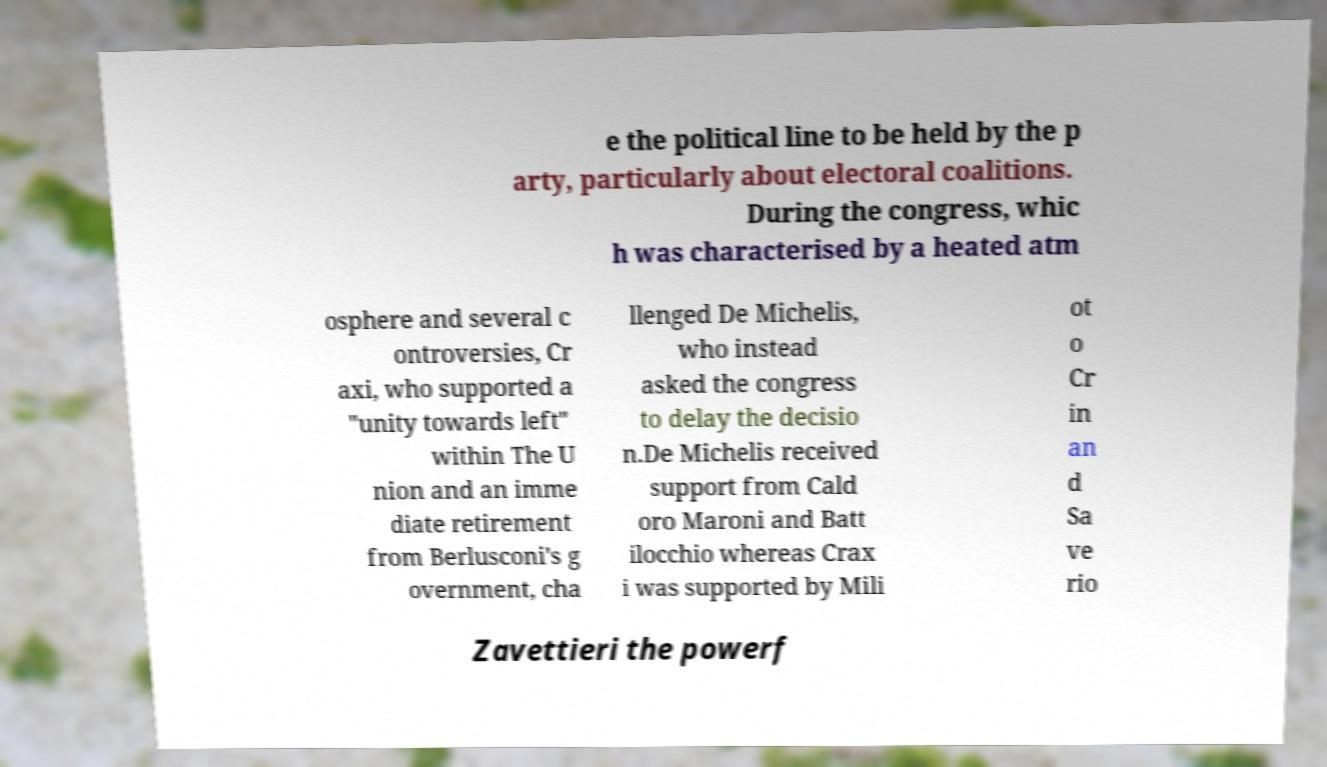Please identify and transcribe the text found in this image. e the political line to be held by the p arty, particularly about electoral coalitions. During the congress, whic h was characterised by a heated atm osphere and several c ontroversies, Cr axi, who supported a "unity towards left" within The U nion and an imme diate retirement from Berlusconi's g overnment, cha llenged De Michelis, who instead asked the congress to delay the decisio n.De Michelis received support from Cald oro Maroni and Batt ilocchio whereas Crax i was supported by Mili ot o Cr in an d Sa ve rio Zavettieri the powerf 